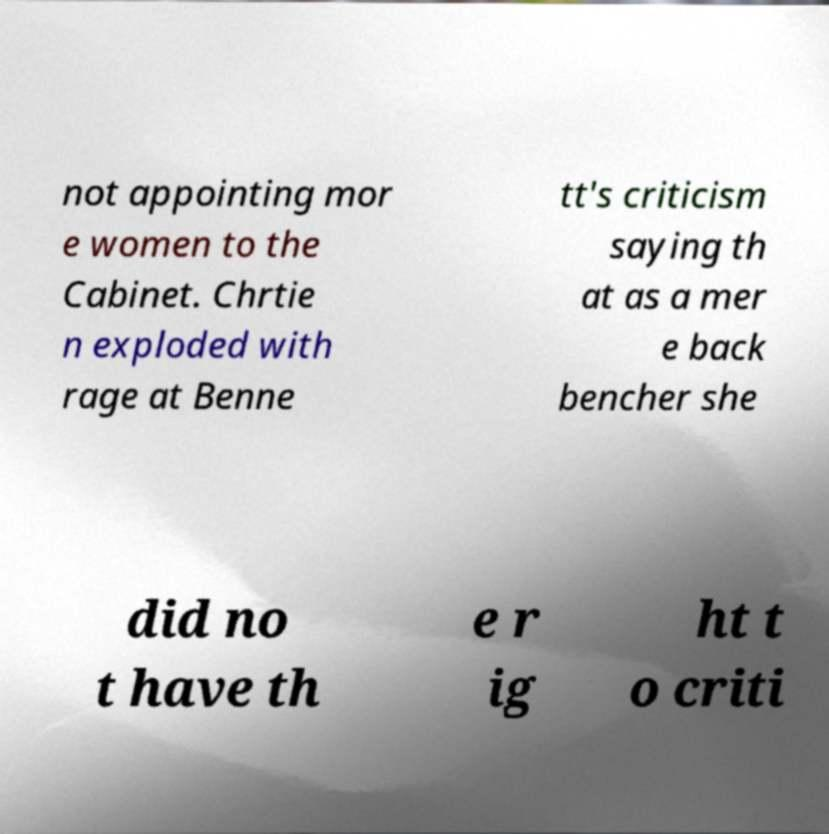For documentation purposes, I need the text within this image transcribed. Could you provide that? not appointing mor e women to the Cabinet. Chrtie n exploded with rage at Benne tt's criticism saying th at as a mer e back bencher she did no t have th e r ig ht t o criti 